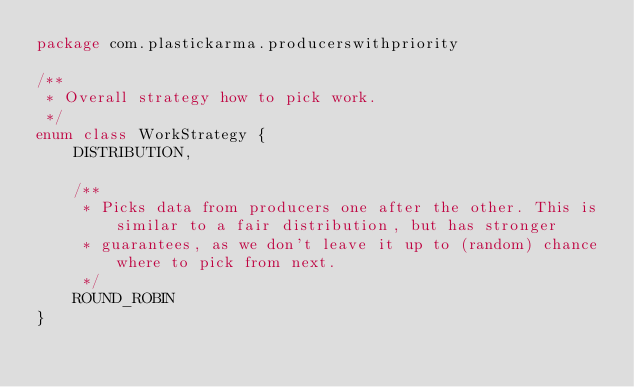<code> <loc_0><loc_0><loc_500><loc_500><_Kotlin_>package com.plastickarma.producerswithpriority

/**
 * Overall strategy how to pick work.
 */
enum class WorkStrategy {
    DISTRIBUTION,

    /**
     * Picks data from producers one after the other. This is similar to a fair distribution, but has stronger
     * guarantees, as we don't leave it up to (random) chance where to pick from next.
     */
    ROUND_ROBIN
}
</code> 